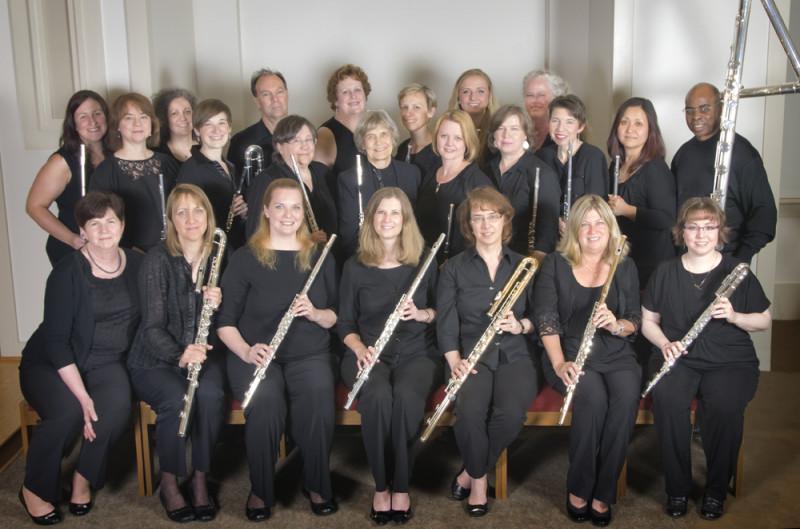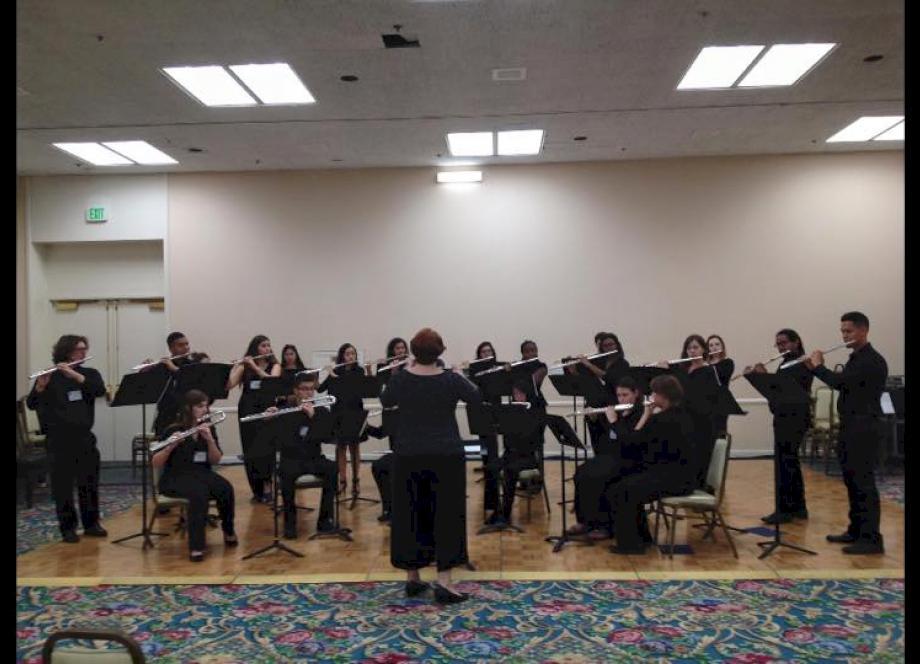The first image is the image on the left, the second image is the image on the right. Examine the images to the left and right. Is the description "Several musicians in black pose for a picture with their instruments in one of the images." accurate? Answer yes or no. Yes. The first image is the image on the left, the second image is the image on the right. Given the left and right images, does the statement "The left image shows at least one row of mostly women facing forward, dressed in black, and holding an instrument but not playing it." hold true? Answer yes or no. Yes. 